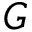Convert formula to latex. <formula><loc_0><loc_0><loc_500><loc_500>G</formula> 